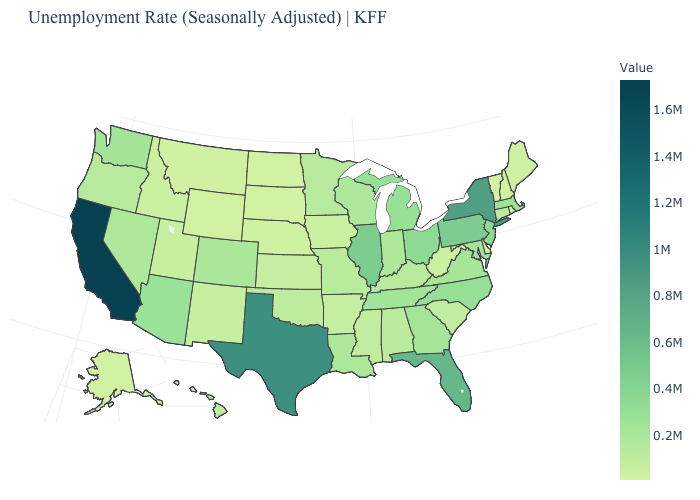Does Vermont have the lowest value in the USA?
Give a very brief answer. Yes. Which states have the highest value in the USA?
Write a very short answer. California. Among the states that border New York , which have the lowest value?
Be succinct. Vermont. Which states have the highest value in the USA?
Be succinct. California. Which states have the highest value in the USA?
Be succinct. California. 